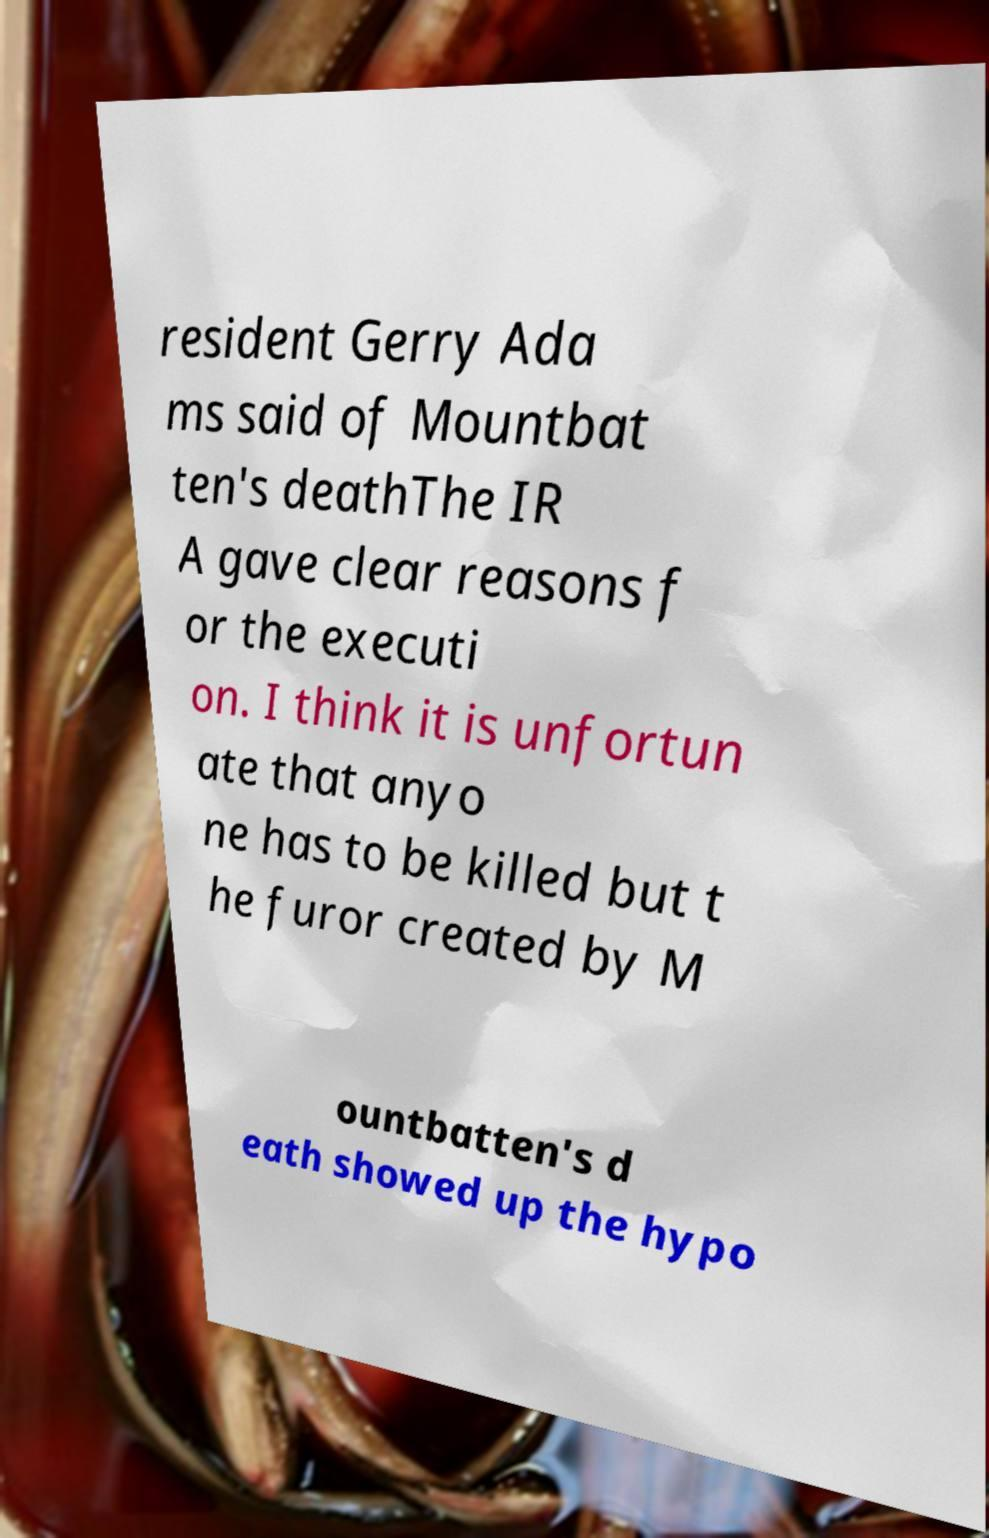Can you read and provide the text displayed in the image?This photo seems to have some interesting text. Can you extract and type it out for me? resident Gerry Ada ms said of Mountbat ten's deathThe IR A gave clear reasons f or the executi on. I think it is unfortun ate that anyo ne has to be killed but t he furor created by M ountbatten's d eath showed up the hypo 